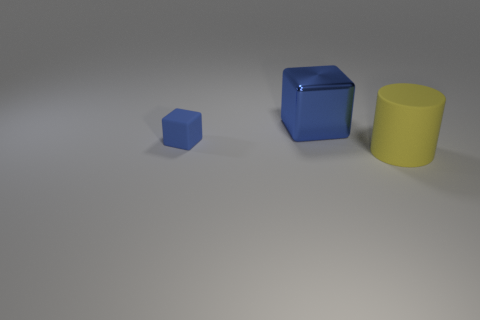Add 3 large green blocks. How many objects exist? 6 Subtract 1 blocks. How many blocks are left? 1 Subtract all blocks. How many objects are left? 1 Add 1 small blue cubes. How many small blue cubes are left? 2 Add 1 tiny cyan rubber cylinders. How many tiny cyan rubber cylinders exist? 1 Subtract 0 gray balls. How many objects are left? 3 Subtract all purple cylinders. Subtract all brown spheres. How many cylinders are left? 1 Subtract all spheres. Subtract all small blue blocks. How many objects are left? 2 